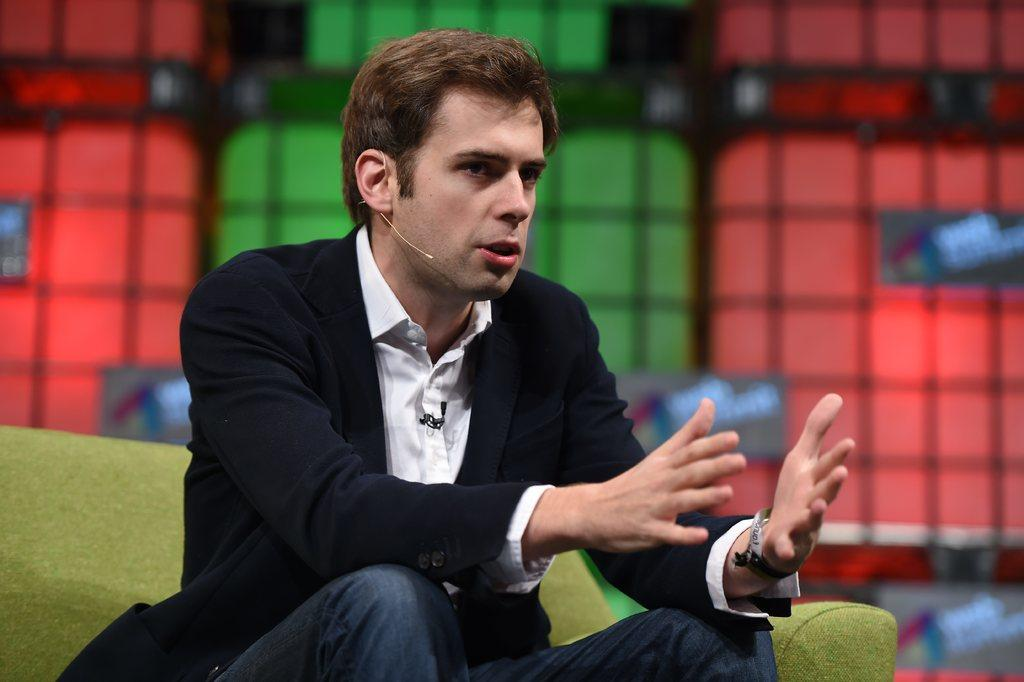Who or what is the main subject in the image? There is a person in the image. What is the person doing in the image? The person is sitting on a couch. Can you describe the background of the image? The background of the image is blurred. What type of sack can be seen on the roof in the image? There is no sack or roof present in the image; it only features a person sitting on a couch with a blurred background. 